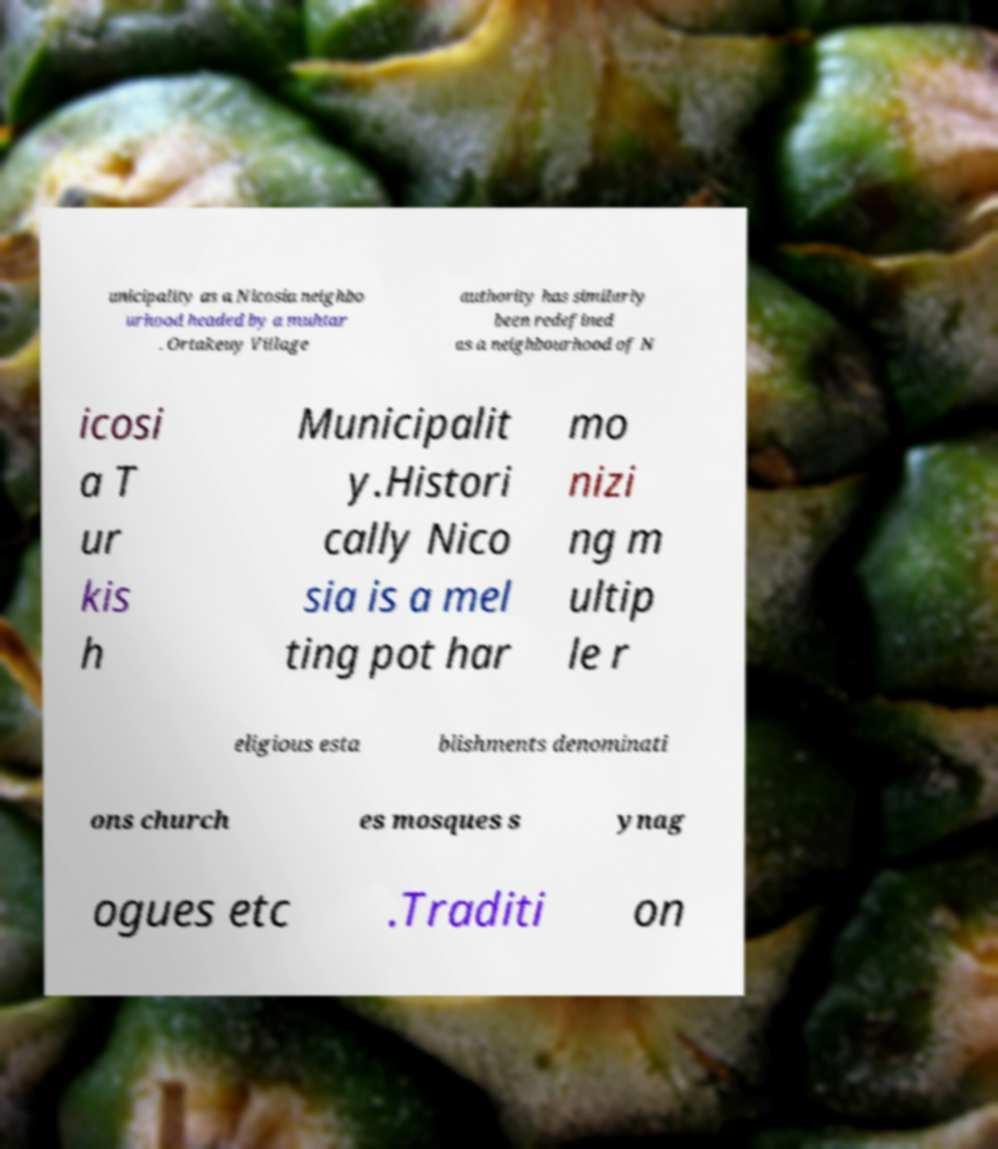Please read and relay the text visible in this image. What does it say? unicipality as a Nicosia neighbo urhood headed by a muhtar . Ortakeuy Village authority has similarly been redefined as a neighbourhood of N icosi a T ur kis h Municipalit y.Histori cally Nico sia is a mel ting pot har mo nizi ng m ultip le r eligious esta blishments denominati ons church es mosques s ynag ogues etc .Traditi on 